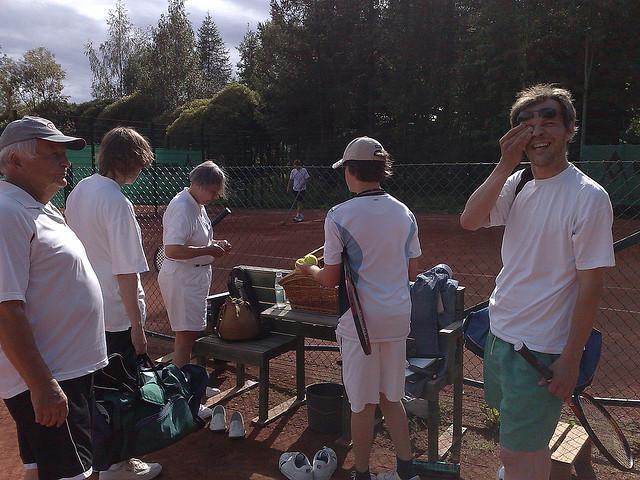How many dressed in white?
Give a very brief answer. 6. How many people are visible?
Give a very brief answer. 5. 